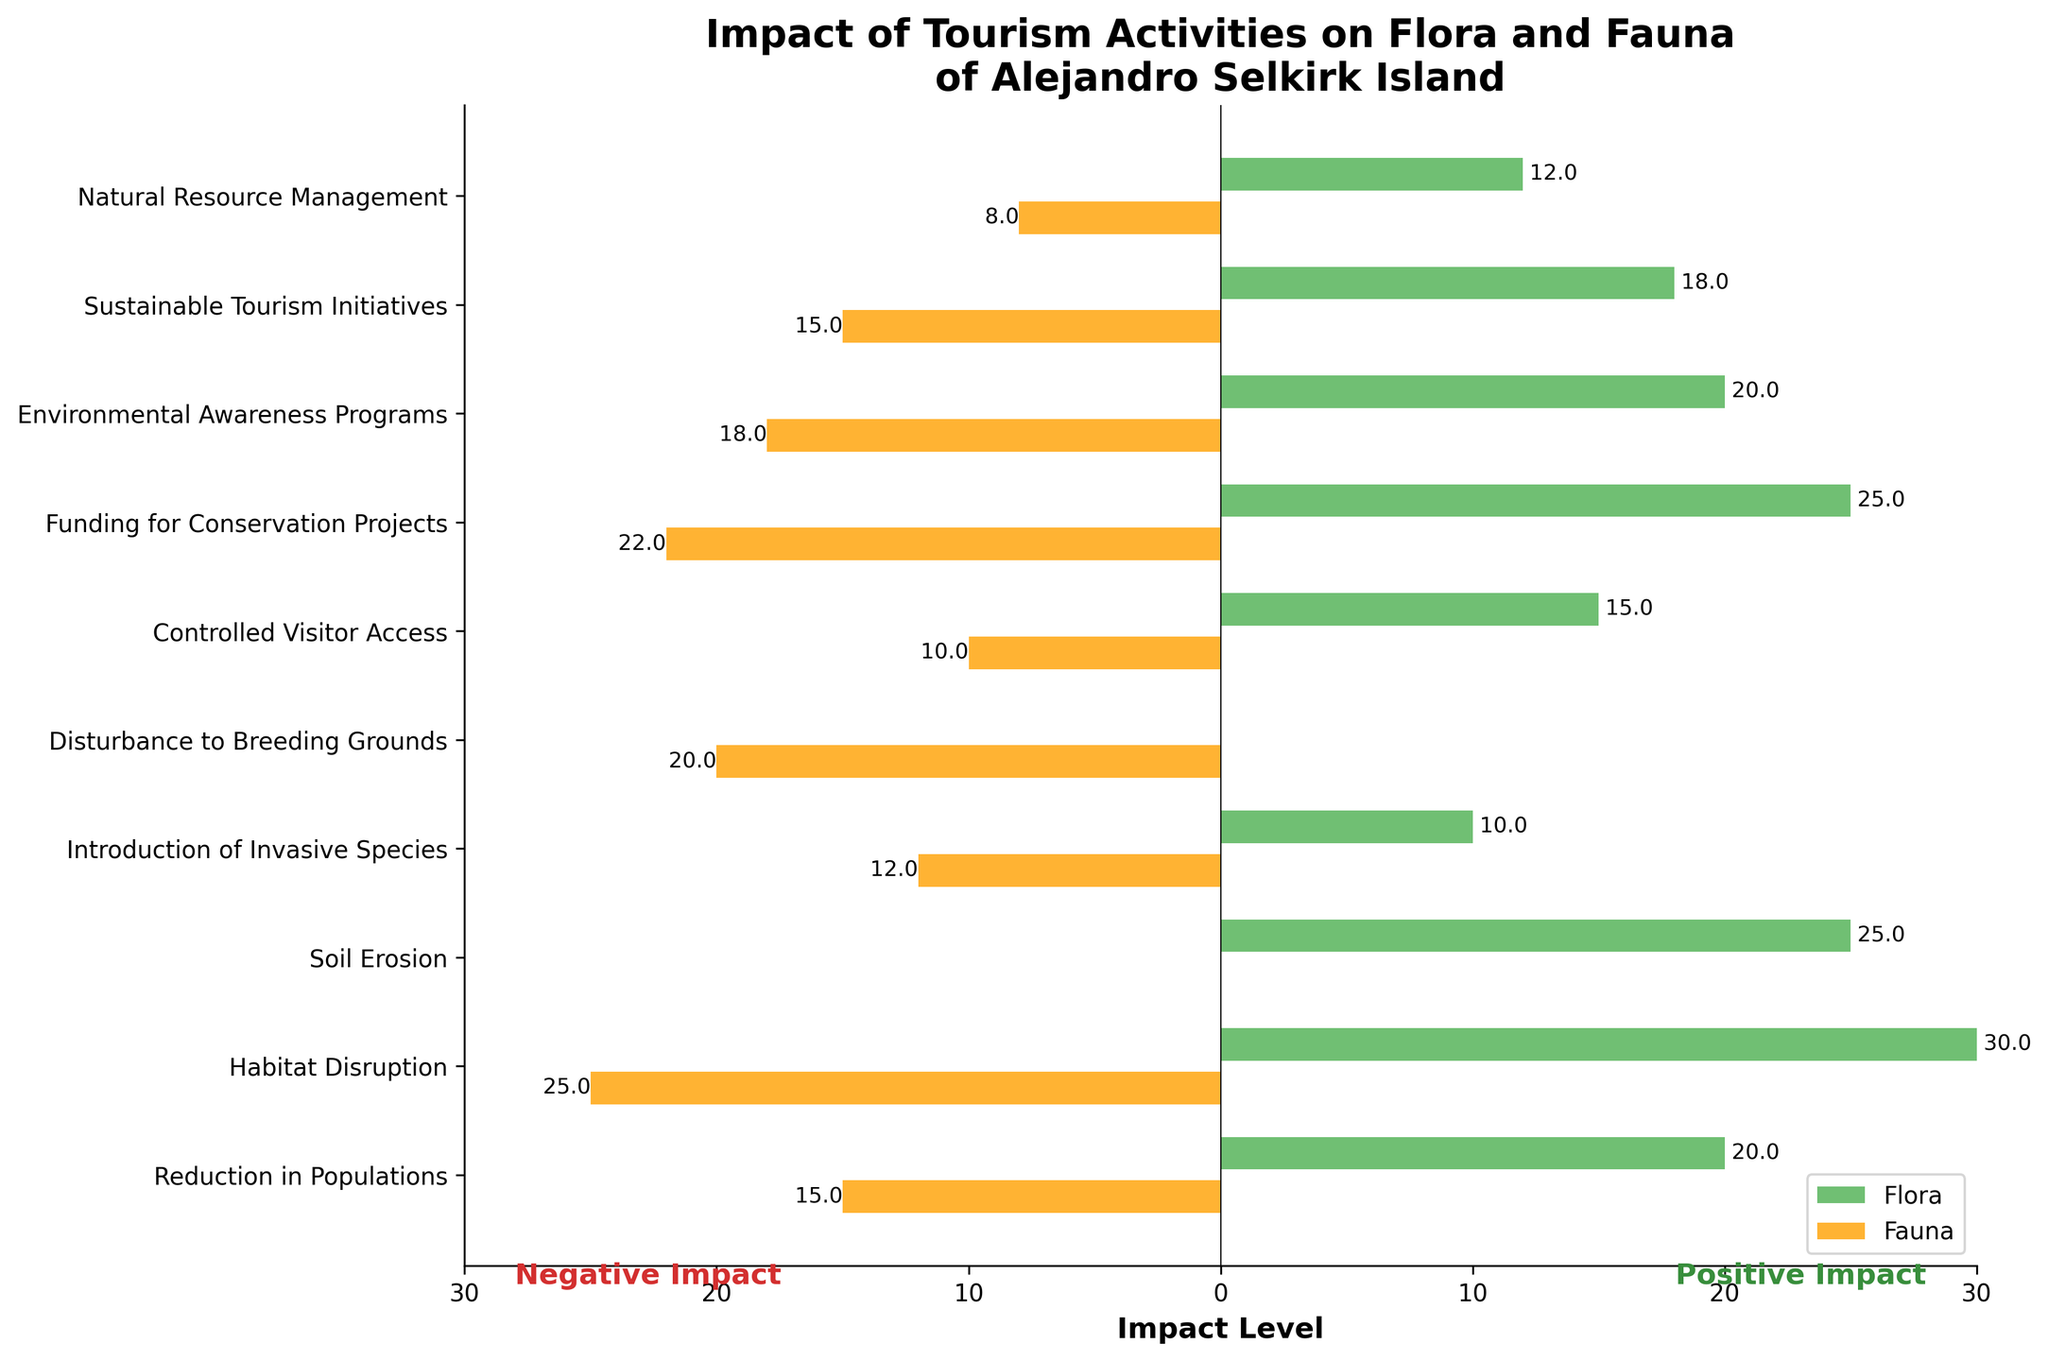Which metric shows the greatest negative impact on flora? Look at the green bars on the negative side. The "Habitat Disruption" bar is the longest.
Answer: Habitat Disruption What is the total positive impact level on fauna for all metrics? Sum the absolute values of the orange bars on the positive side: 10 + 22 + 18 + 15 + 8 = 73.
Answer: 73 Which aspect has a larger negative impact: Soil Erosion on flora or Disturbance to Breeding Grounds on fauna? Compare the lengths of the green bar for "Soil Erosion" on flora and the orange bar for "Disturbance to Breeding Grounds" on fauna. "Soil Erosion" on flora is 25, and "Disturbance to Breeding Grounds" on fauna is 20.
Answer: Soil Erosion on flora How does Funding for Conservation Projects compare between flora and fauna? Both are represented by the bars for "Funding for Conservation Projects". The green bar (flora) is 25, and the orange bar (fauna) is 22.
Answer: Flora has a slightly higher impact at 25 compared to fauna at 22 Which positive metric has the smallest impact on fauna? Look at the shortest orange bar on the positive side. "Natural Resource Management" has the smallest bar at 8.
Answer: Natural Resource Management How many metrics show a positive impact on flora? Count the green bars on the positive side. There are 5 bars for the metrics "Controlled Visitor Access", "Funding for Conservation Projects", "Environmental Awareness Programs", "Sustainable Tourism Initiatives", and "Natural Resource Management".
Answer: 5 What is the difference in negative impact levels between Habitat Disruption on flora and fauna? Look at the lengths of the green and orange bars for "Habitat Disruption". Flora is 30, fauna is 25. The difference is 30 - 25 = 5.
Answer: 5 Considering only positive impacts, which metric shows the closest impact levels on both flora and fauna? Compare the lengths of green and orange bars on the positive side and find the pairs with the closest values. "Sustainable Tourism Initiatives" has 18 for flora and 15 for fauna, which are close values.
Answer: Sustainable Tourism Initiatives 